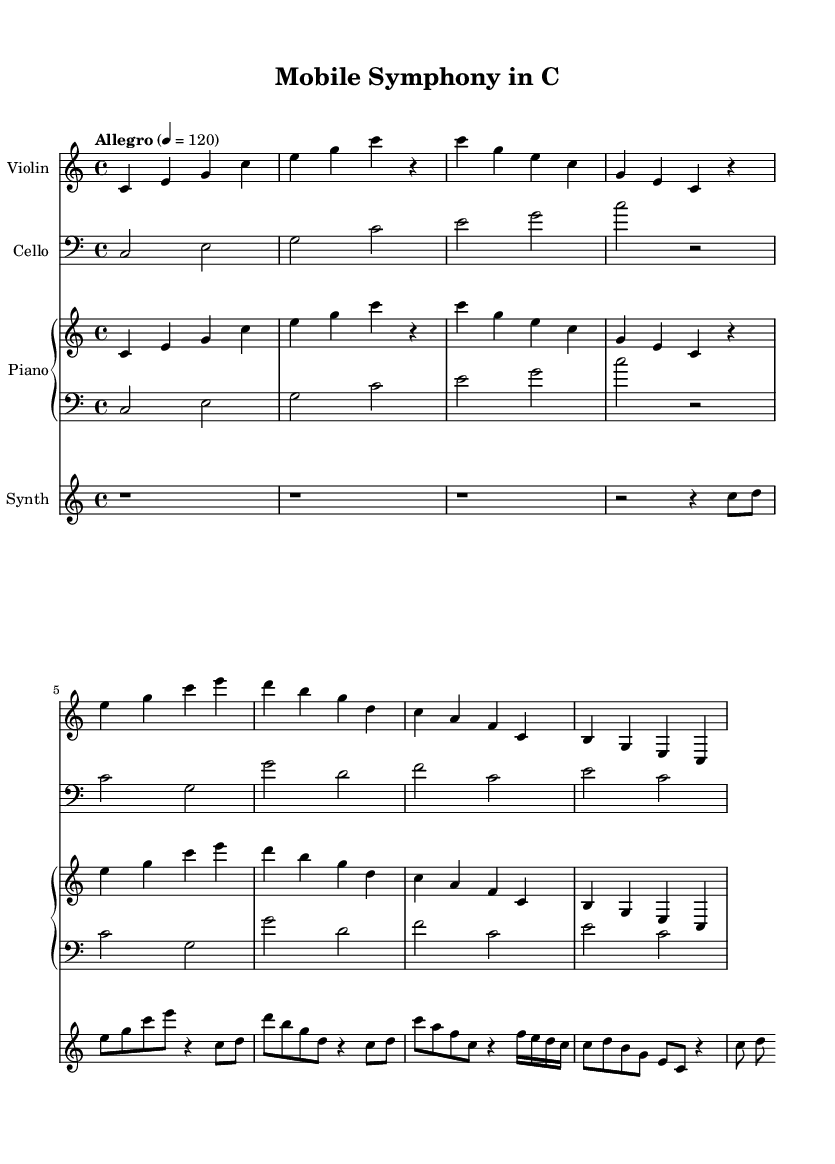What is the key signature of this music? The key signature is indicated at the beginning of the piece. It shows no sharps or flats, which signifies it is in C major.
Answer: C major What is the time signature of this piece? The time signature is typically found at the start of the music. It shows 4 beats per measure, which is indicated as 4/4.
Answer: 4/4 What is the tempo marking? The tempo marking appears at the beginning just below the title. It states "Allegro" with a metronome marking of quarter note equals 120.
Answer: Allegro 4 = 120 How many instruments are there in the score? By examining the score layout, we can count the number of distinct staves provided, which shows there are four instruments: violin, cello, piano (split into right and left hands), and synthesizer.
Answer: Four Which instrument has the lowest pitch range? Looking at the clefs used, the cello is in bass clef, which represents lower pitches compared to the treble clef used by the violin and synthesizer, and the piano, especially in the left hand.
Answer: Cello What type of sounds does the synthesizer play in this piece? The synthesizer part features electronic sounds and synthesized notes, contrasting with the acoustic instruments, and is evident by its rhythmic patterns and different articulations that differ from the strings and piano.
Answer: Synthesized sounds What musical technique is prevalent in the combination of instruments in this piece? Analyzing the interaction between the classical instruments (violin, cello, piano) and the synthesized sounds, we observe a blending of acoustic and digital textures, creating a fusion effect that stands out in the score.
Answer: Fusion effect 